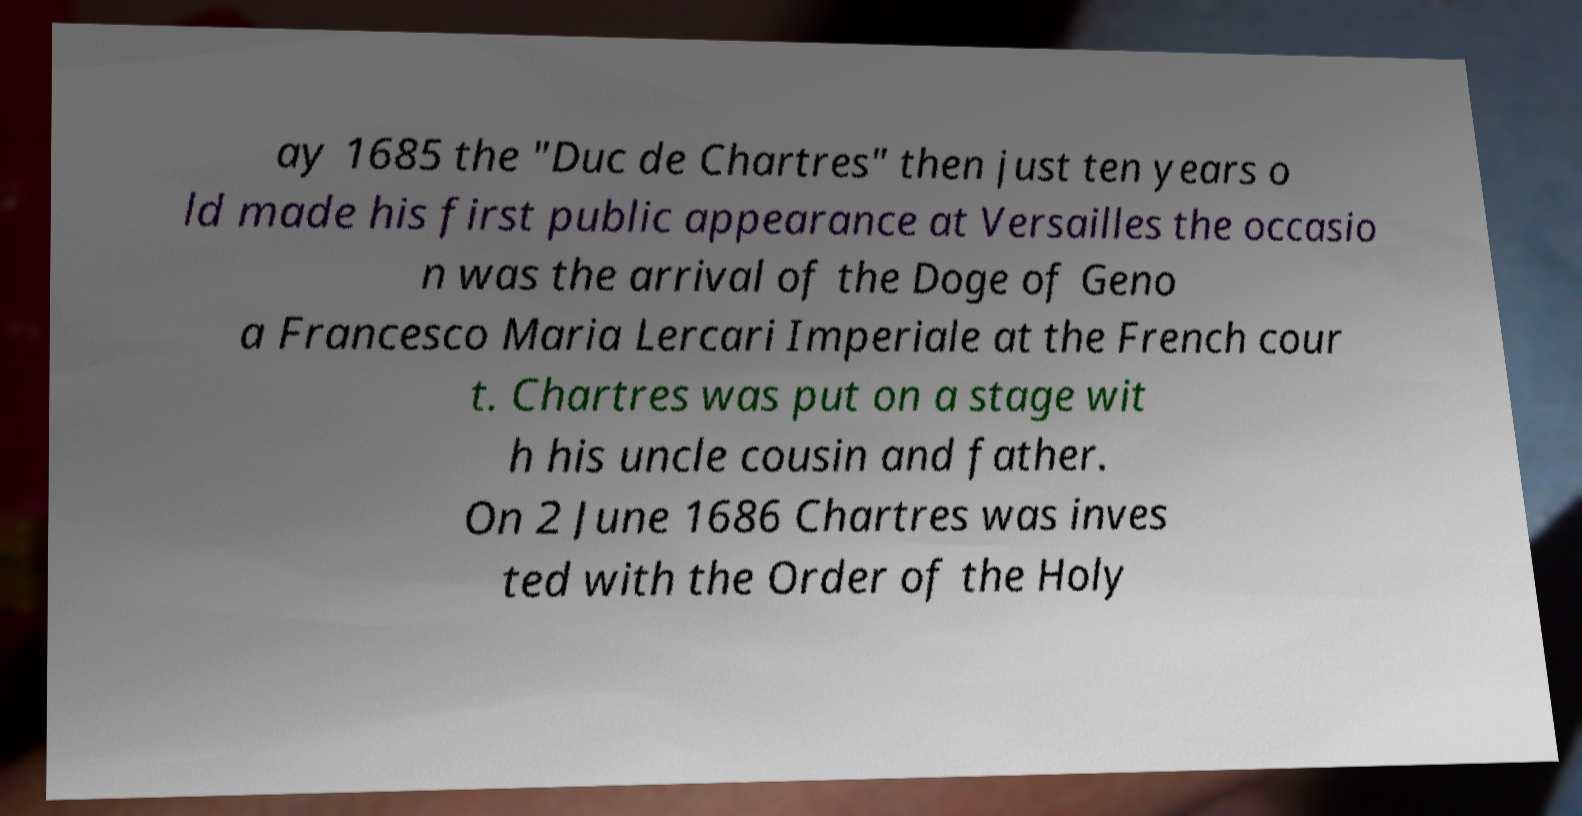Please read and relay the text visible in this image. What does it say? ay 1685 the "Duc de Chartres" then just ten years o ld made his first public appearance at Versailles the occasio n was the arrival of the Doge of Geno a Francesco Maria Lercari Imperiale at the French cour t. Chartres was put on a stage wit h his uncle cousin and father. On 2 June 1686 Chartres was inves ted with the Order of the Holy 